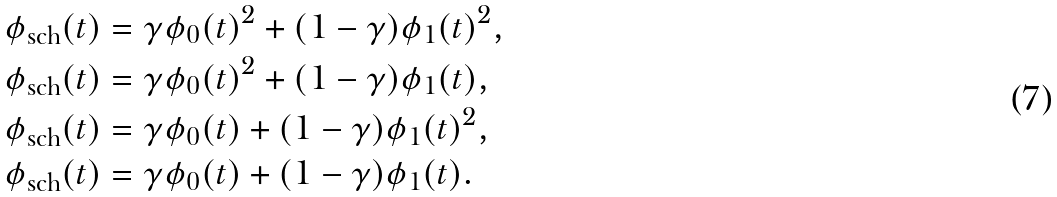Convert formula to latex. <formula><loc_0><loc_0><loc_500><loc_500>\phi _ { \text {sch} } ( t ) & = \gamma \phi _ { 0 } ( t ) ^ { 2 } + ( 1 - \gamma ) \phi _ { 1 } ( t ) ^ { 2 } , \\ \phi _ { \text {sch} } ( t ) & = \gamma \phi _ { 0 } ( t ) ^ { 2 } + ( 1 - \gamma ) \phi _ { 1 } ( t ) , \\ \phi _ { \text {sch} } ( t ) & = \gamma \phi _ { 0 } ( t ) + ( 1 - \gamma ) \phi _ { 1 } ( t ) ^ { 2 } , \\ \phi _ { \text {sch} } ( t ) & = \gamma \phi _ { 0 } ( t ) + ( 1 - \gamma ) \phi _ { 1 } ( t ) .</formula> 